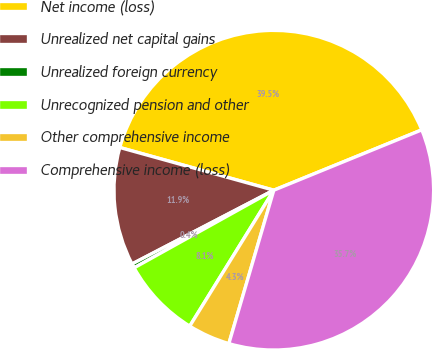<chart> <loc_0><loc_0><loc_500><loc_500><pie_chart><fcel>Net income (loss)<fcel>Unrealized net capital gains<fcel>Unrealized foreign currency<fcel>Unrecognized pension and other<fcel>Other comprehensive income<fcel>Comprehensive income (loss)<nl><fcel>39.53%<fcel>11.94%<fcel>0.44%<fcel>8.11%<fcel>4.28%<fcel>35.7%<nl></chart> 